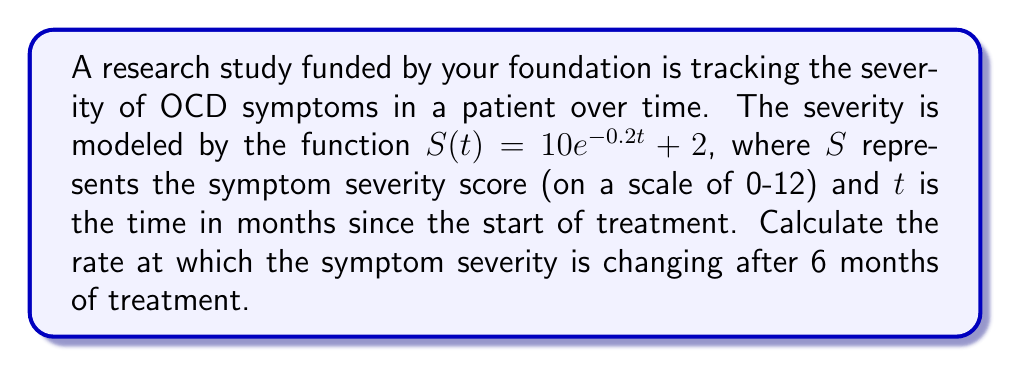Solve this math problem. To find the rate of change in OCD symptom severity at 6 months, we need to calculate the derivative of $S(t)$ and evaluate it at $t=6$.

Step 1: Find the derivative of $S(t)$
$$\frac{d}{dt}S(t) = \frac{d}{dt}(10e^{-0.2t} + 2)$$
$$S'(t) = 10 \cdot (-0.2)e^{-0.2t} + 0$$
$$S'(t) = -2e^{-0.2t}$$

Step 2: Evaluate $S'(t)$ at $t=6$
$$S'(6) = -2e^{-0.2(6)}$$
$$S'(6) = -2e^{-1.2}$$
$$S'(6) \approx -0.6015$$

The negative value indicates that the symptom severity is decreasing.
Answer: $-0.6015$ points per month 